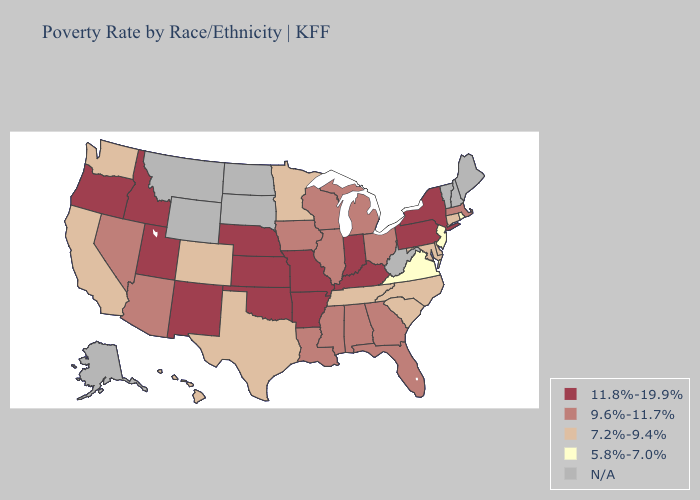Among the states that border Kansas , does Oklahoma have the lowest value?
Write a very short answer. No. Name the states that have a value in the range 9.6%-11.7%?
Write a very short answer. Alabama, Arizona, Florida, Georgia, Illinois, Iowa, Louisiana, Massachusetts, Michigan, Mississippi, Nevada, Ohio, Wisconsin. What is the highest value in states that border Texas?
Keep it brief. 11.8%-19.9%. What is the value of Wisconsin?
Write a very short answer. 9.6%-11.7%. What is the value of Vermont?
Write a very short answer. N/A. Does the first symbol in the legend represent the smallest category?
Be succinct. No. Does Iowa have the highest value in the MidWest?
Keep it brief. No. Name the states that have a value in the range 11.8%-19.9%?
Give a very brief answer. Arkansas, Idaho, Indiana, Kansas, Kentucky, Missouri, Nebraska, New Mexico, New York, Oklahoma, Oregon, Pennsylvania, Utah. Among the states that border Nebraska , does Colorado have the lowest value?
Concise answer only. Yes. Name the states that have a value in the range 5.8%-7.0%?
Quick response, please. New Jersey, Rhode Island, Virginia. Which states have the highest value in the USA?
Answer briefly. Arkansas, Idaho, Indiana, Kansas, Kentucky, Missouri, Nebraska, New Mexico, New York, Oklahoma, Oregon, Pennsylvania, Utah. What is the value of Idaho?
Write a very short answer. 11.8%-19.9%. Does Massachusetts have the highest value in the Northeast?
Short answer required. No. What is the value of Illinois?
Be succinct. 9.6%-11.7%. What is the lowest value in states that border New Mexico?
Keep it brief. 7.2%-9.4%. 